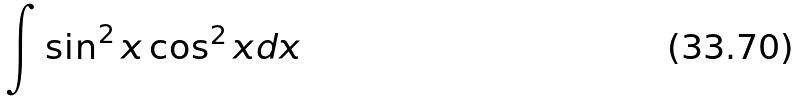Convert formula to latex. <formula><loc_0><loc_0><loc_500><loc_500>\int \sin ^ { 2 } x \cos ^ { 2 } x d x</formula> 